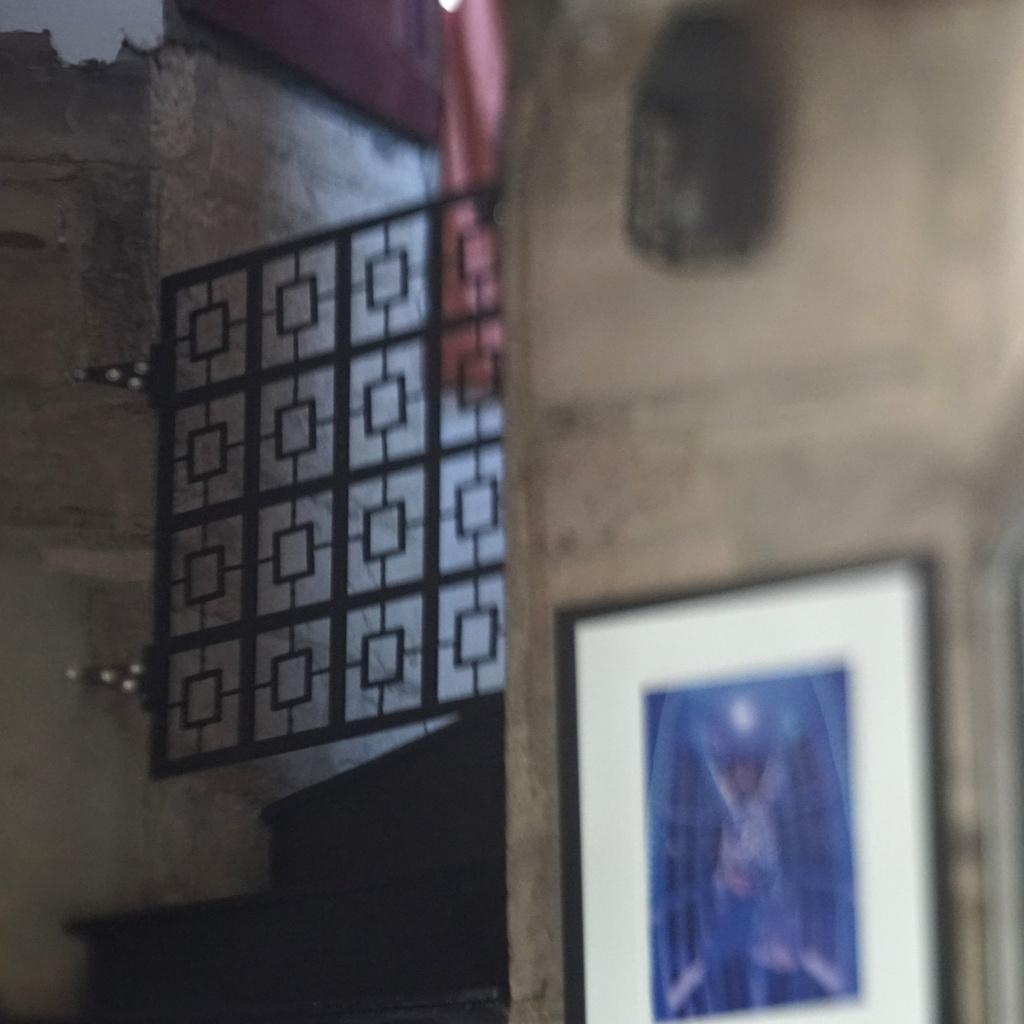What is hanging on the wall in the image? There is a frame on the wall. What can be seen in the image besides the frame on the wall? There is a grill visible in the image. How does the frame breathe in the image? Frames do not breathe, as they are inanimate objects. 